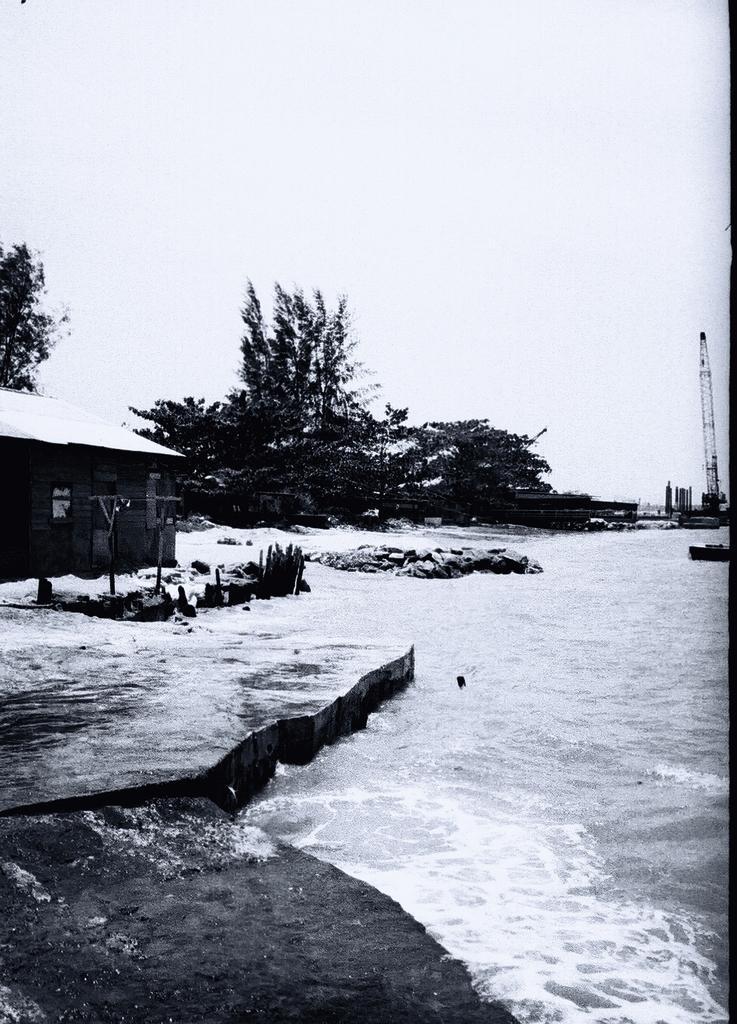Describe this image in one or two sentences. In this picture we can see rocks, water, house, tower, trees, some objects and in the background we can see the sky. 